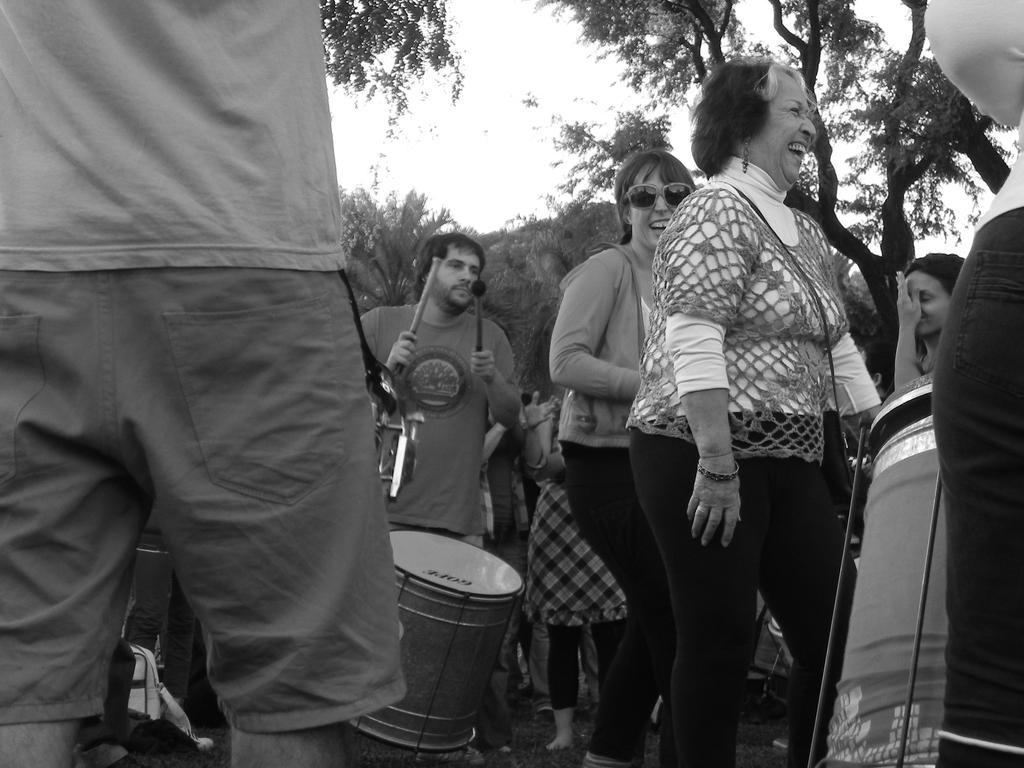Could you give a brief overview of what you see in this image? In this picture there are group of people standing and there is a person standing and holding the drumsticks and there are drums. At the back there are trees. At the top there is sky. At the bottom there are bags on the grass. 